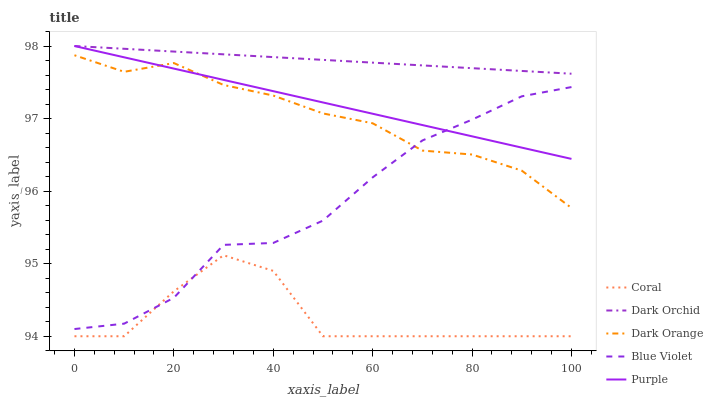Does Dark Orange have the minimum area under the curve?
Answer yes or no. No. Does Dark Orange have the maximum area under the curve?
Answer yes or no. No. Is Dark Orange the smoothest?
Answer yes or no. No. Is Dark Orange the roughest?
Answer yes or no. No. Does Dark Orange have the lowest value?
Answer yes or no. No. Does Dark Orange have the highest value?
Answer yes or no. No. Is Coral less than Dark Orchid?
Answer yes or no. Yes. Is Dark Orchid greater than Dark Orange?
Answer yes or no. Yes. Does Coral intersect Dark Orchid?
Answer yes or no. No. 